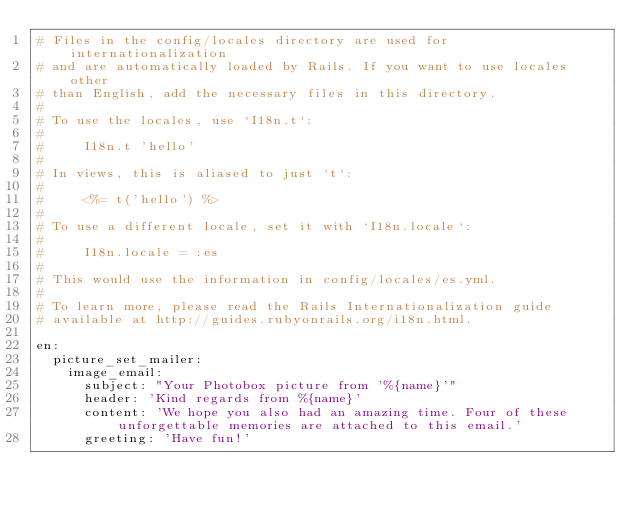<code> <loc_0><loc_0><loc_500><loc_500><_YAML_># Files in the config/locales directory are used for internationalization
# and are automatically loaded by Rails. If you want to use locales other
# than English, add the necessary files in this directory.
#
# To use the locales, use `I18n.t`:
#
#     I18n.t 'hello'
#
# In views, this is aliased to just `t`:
#
#     <%= t('hello') %>
#
# To use a different locale, set it with `I18n.locale`:
#
#     I18n.locale = :es
#
# This would use the information in config/locales/es.yml.
#
# To learn more, please read the Rails Internationalization guide
# available at http://guides.rubyonrails.org/i18n.html.

en:
  picture_set_mailer:
    image_email:
      subject: "Your Photobox picture from '%{name}'"
      header: 'Kind regards from %{name}'
      content: 'We hope you also had an amazing time. Four of these unforgettable memories are attached to this email.'
      greeting: 'Have fun!'
</code> 